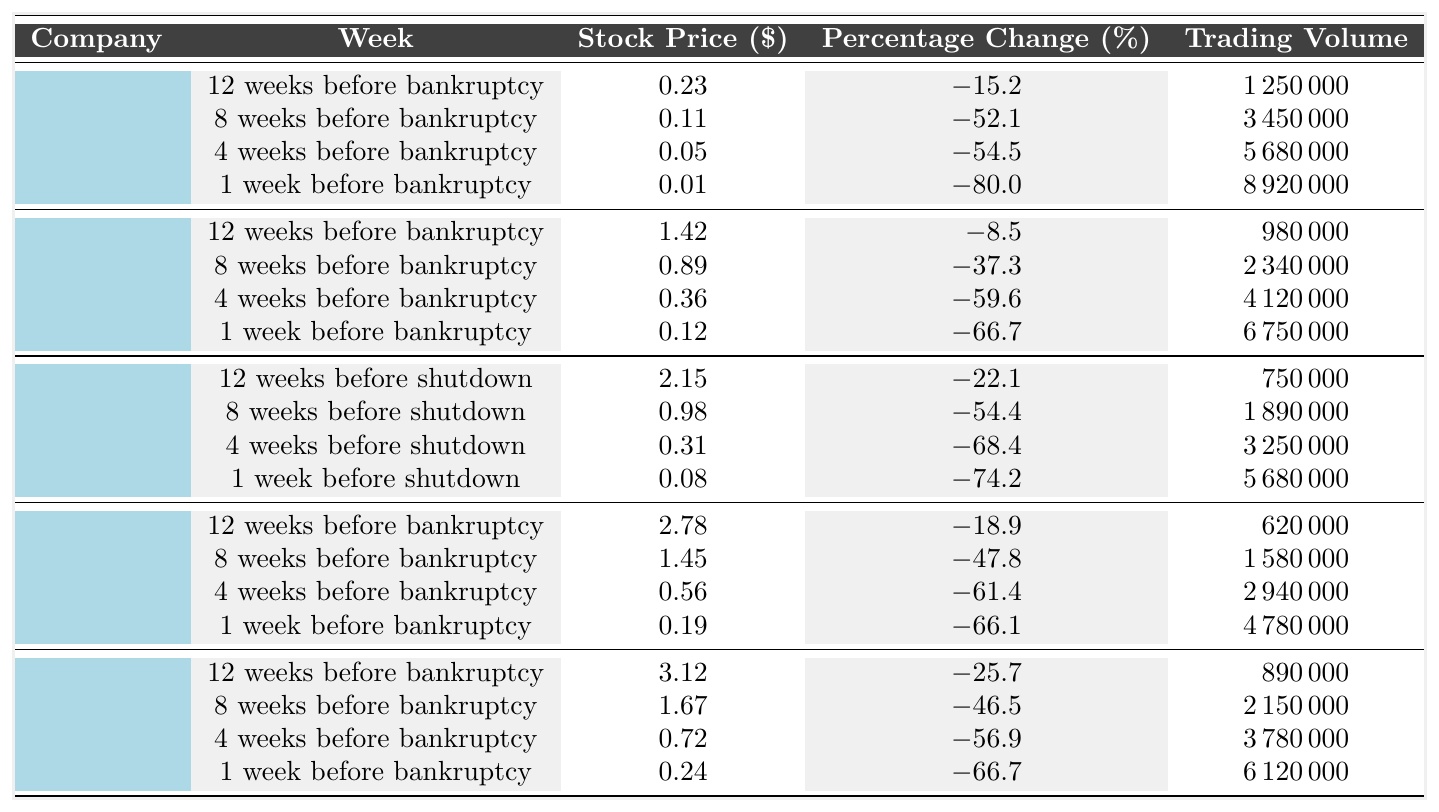What was the stock price of Blockbuster 8 weeks before bankruptcy? The table shows that the stock price of Blockbuster 8 weeks before bankruptcy is $0.11.
Answer: $0.11 What was the percentage change in stock price for Pets.com 4 weeks before bankruptcy? According to the table, the percentage change in stock price for Pets.com 4 weeks before bankruptcy is -61.4%.
Answer: -61.4% Which company had the highest stock price 12 weeks before bankruptcy? The table indicates that Webvan had the highest stock price at $3.12, 12 weeks before bankruptcy.
Answer: Webvan What is the total trading volume of RadioShack for the weeks listed? The trading volumes for RadioShack are 980000, 2340000, 4120000, and 6750000. Summing these gives 980000 + 2340000 + 4120000 + 6750000 = 15350000.
Answer: 15350000 What percentage change did Theranos experience in the week before shutdown? The table specifies that Theranos had a percentage change of -74.2% in the week before shutdown.
Answer: -74.2% Did any company see a stock price above $3.00 in the weeks leading up to bankruptcy or shutdown? From the data, Webvan had a stock price of $3.12 12 weeks before bankruptcy, indicating that at least one company did see a stock price above $3.00.
Answer: Yes Which company experienced the greatest percentage drop in stock price 1 week before bankruptcy? Analyzing the data, Blockbuster had the most significant percentage drop at -80.0% one week before bankruptcy.
Answer: Blockbuster What was the average stock price of Webvan during the 4 weeks leading up to bankruptcy? The stock prices of Webvan are 3.12, 1.67, 0.72, and 0.24. Summing these gives 3.12 + 1.67 + 0.72 + 0.24 = 5.75, and dividing by 4 (the number of weeks) results in an average stock price of 5.75 / 4 = 1.4375.
Answer: 1.44 Which company had the highest trading volume and during which week? By checking the trading volume data, it appears that Blockbuster had the highest trading volume of 8920000 in the week before bankruptcy.
Answer: Blockbuster, 1 week before bankruptcy What was the stock price of RadioShack 4 weeks before bankruptcy, and how does it compare to the price 12 weeks before? The table lists RadioShack's stock price as $0.36 four weeks before bankruptcy and $1.42 twelve weeks before. The price decreased by $1.06 over the given period.
Answer: $0.36; decreased by $1.06 